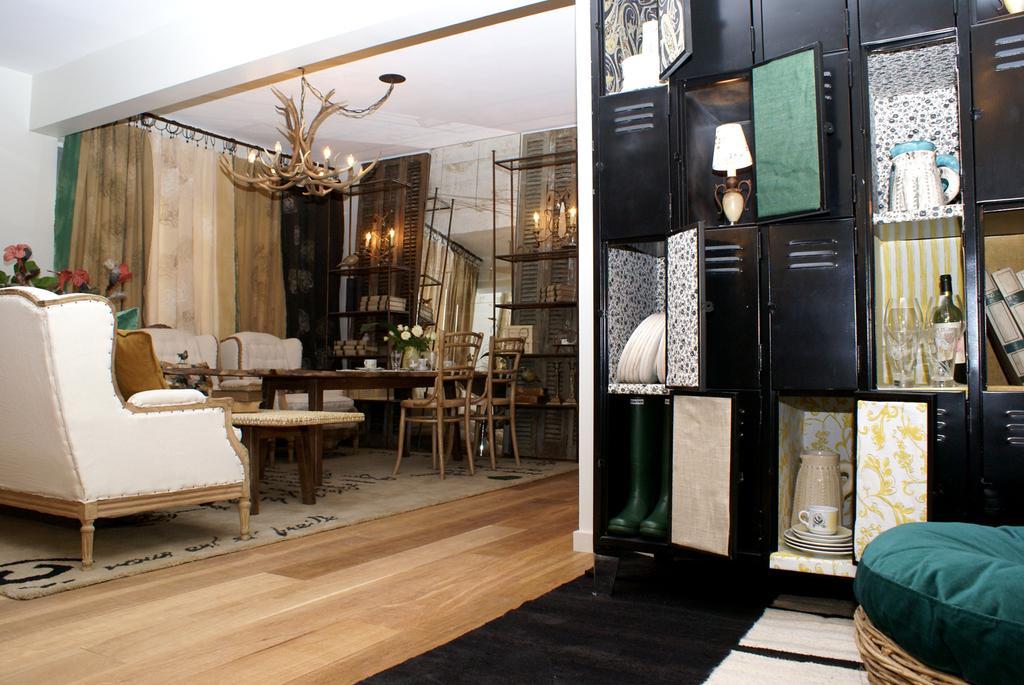Please provide a concise description of this image. There is a room in it,and there is a cupboard which has books,glasses,cups,plates,lamp. In the background there is a curtain and to the roof there is a chandelier and there is a candle on the right corner of the room and there is a table in the middle of the room. And there are sofas,chairs,flower vase. 